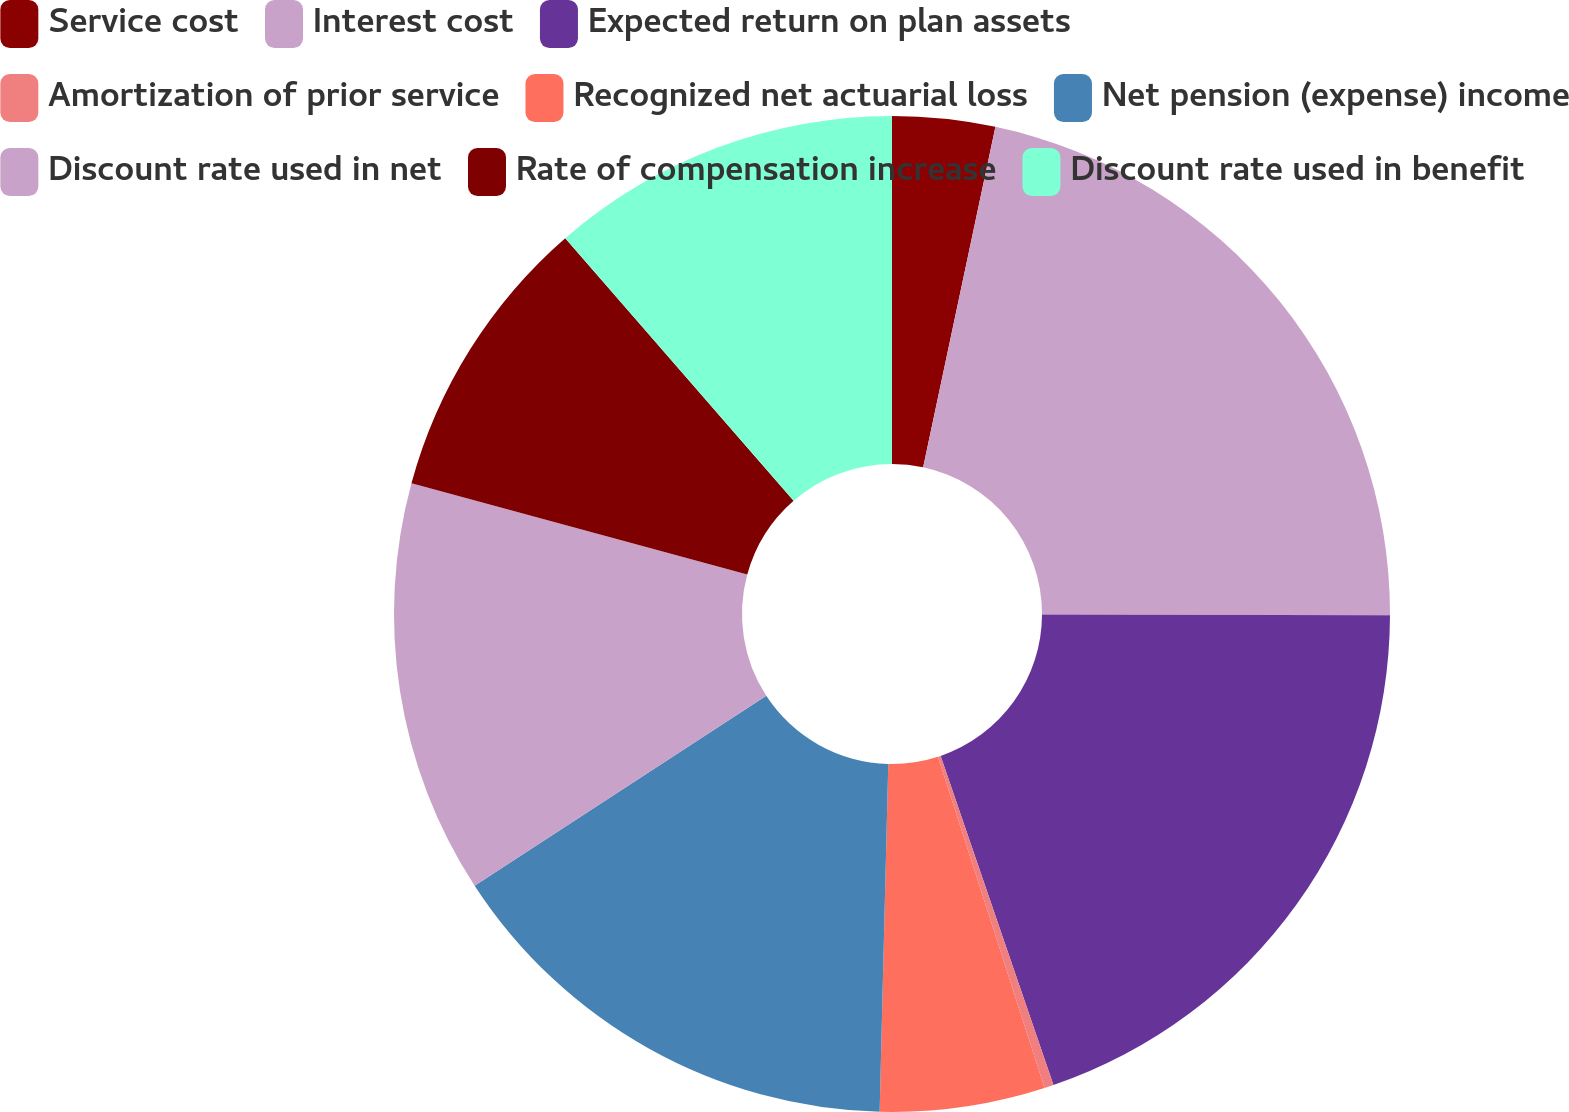Convert chart to OTSL. <chart><loc_0><loc_0><loc_500><loc_500><pie_chart><fcel>Service cost<fcel>Interest cost<fcel>Expected return on plan assets<fcel>Amortization of prior service<fcel>Recognized net actuarial loss<fcel>Net pension (expense) income<fcel>Discount rate used in net<fcel>Rate of compensation increase<fcel>Discount rate used in benefit<nl><fcel>3.33%<fcel>21.71%<fcel>19.7%<fcel>0.3%<fcel>5.35%<fcel>15.42%<fcel>13.41%<fcel>9.38%<fcel>11.39%<nl></chart> 